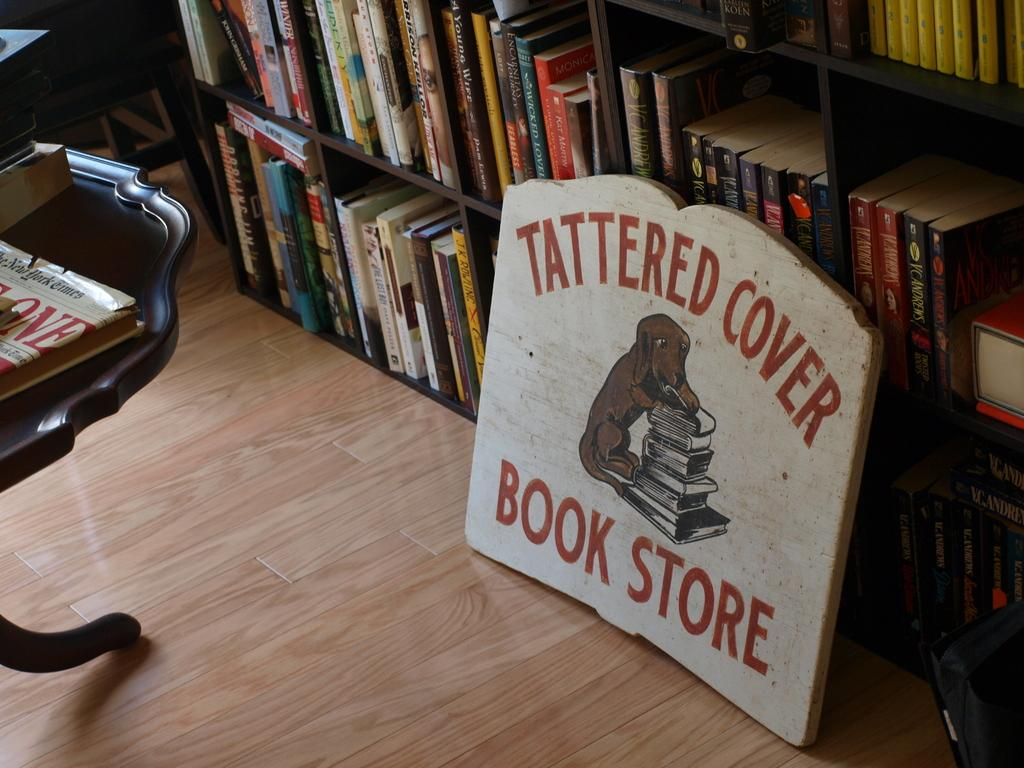<image>
Give a short and clear explanation of the subsequent image. A sign that reads Tattered Cover Book Store. 